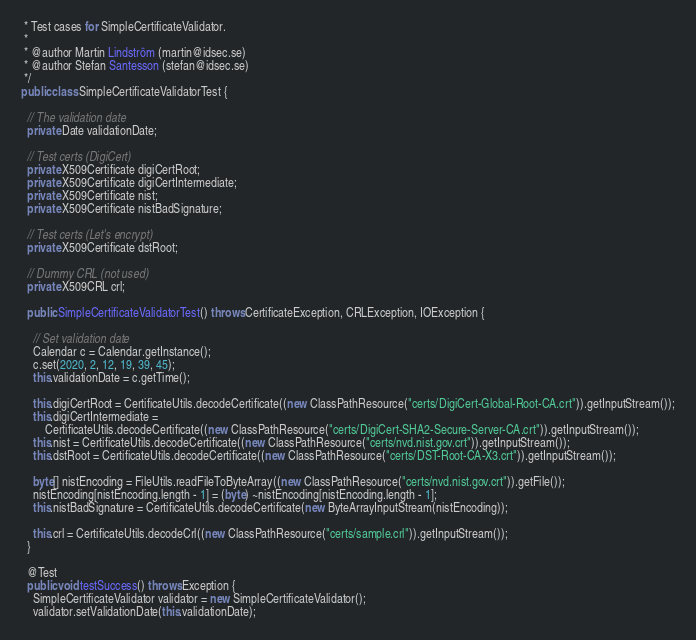<code> <loc_0><loc_0><loc_500><loc_500><_Java_> * Test cases for SimpleCertificateValidator.
 * 
 * @author Martin Lindström (martin@idsec.se)
 * @author Stefan Santesson (stefan@idsec.se)
 */
public class SimpleCertificateValidatorTest {

  // The validation date
  private Date validationDate;

  // Test certs (DigiCert)
  private X509Certificate digiCertRoot;
  private X509Certificate digiCertIntermediate;
  private X509Certificate nist;
  private X509Certificate nistBadSignature;

  // Test certs (Let's encrypt)
  private X509Certificate dstRoot;
  
  // Dummy CRL (not used)
  private X509CRL crl;

  public SimpleCertificateValidatorTest() throws CertificateException, CRLException, IOException {

    // Set validation date
    Calendar c = Calendar.getInstance();
    c.set(2020, 2, 12, 19, 39, 45);
    this.validationDate = c.getTime();

    this.digiCertRoot = CertificateUtils.decodeCertificate((new ClassPathResource("certs/DigiCert-Global-Root-CA.crt")).getInputStream());
    this.digiCertIntermediate =
        CertificateUtils.decodeCertificate((new ClassPathResource("certs/DigiCert-SHA2-Secure-Server-CA.crt")).getInputStream());
    this.nist = CertificateUtils.decodeCertificate((new ClassPathResource("certs/nvd.nist.gov.crt")).getInputStream());
    this.dstRoot = CertificateUtils.decodeCertificate((new ClassPathResource("certs/DST-Root-CA-X3.crt")).getInputStream());
    
    byte[] nistEncoding = FileUtils.readFileToByteArray((new ClassPathResource("certs/nvd.nist.gov.crt")).getFile());
    nistEncoding[nistEncoding.length - 1] = (byte) ~nistEncoding[nistEncoding.length - 1];
    this.nistBadSignature = CertificateUtils.decodeCertificate(new ByteArrayInputStream(nistEncoding));
    
    this.crl = CertificateUtils.decodeCrl((new ClassPathResource("certs/sample.crl")).getInputStream());
  }

  @Test
  public void testSuccess() throws Exception {
    SimpleCertificateValidator validator = new SimpleCertificateValidator();
    validator.setValidationDate(this.validationDate);</code> 